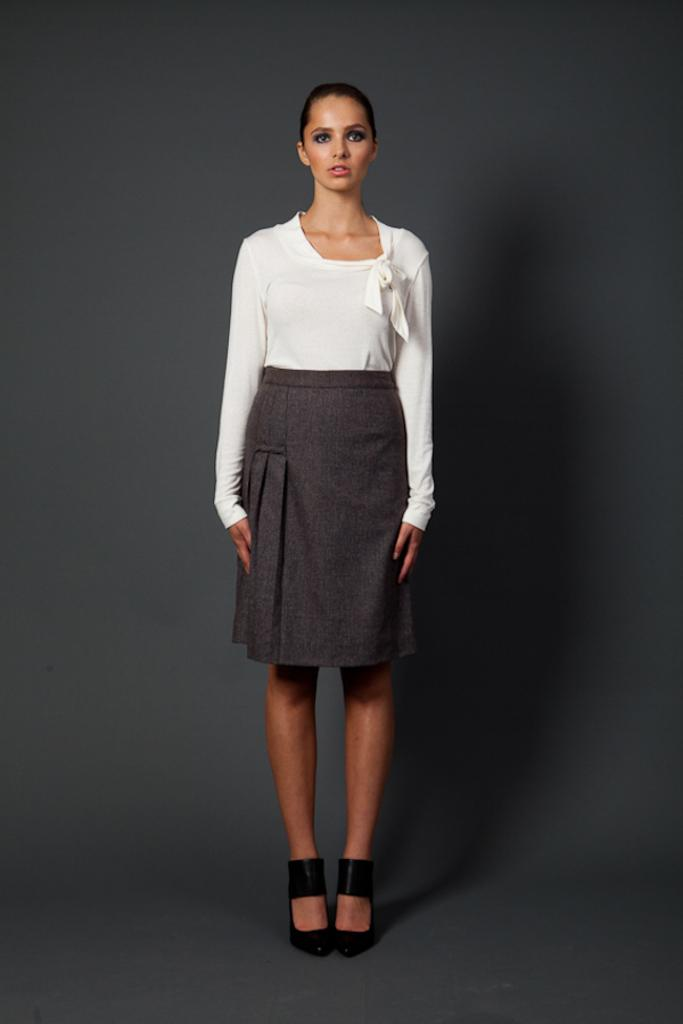Who is present in the image? There is a woman in the image. What is the woman doing in the image? The woman is standing on the floor. What is the woman wearing in the image? The woman is wearing a white color top. What can be seen in the background of the image? There is an ash color wall in the background of the image. What is the title of the book the woman is reading in the image? There is no book present in the image, so it is not possible to determine the title. 